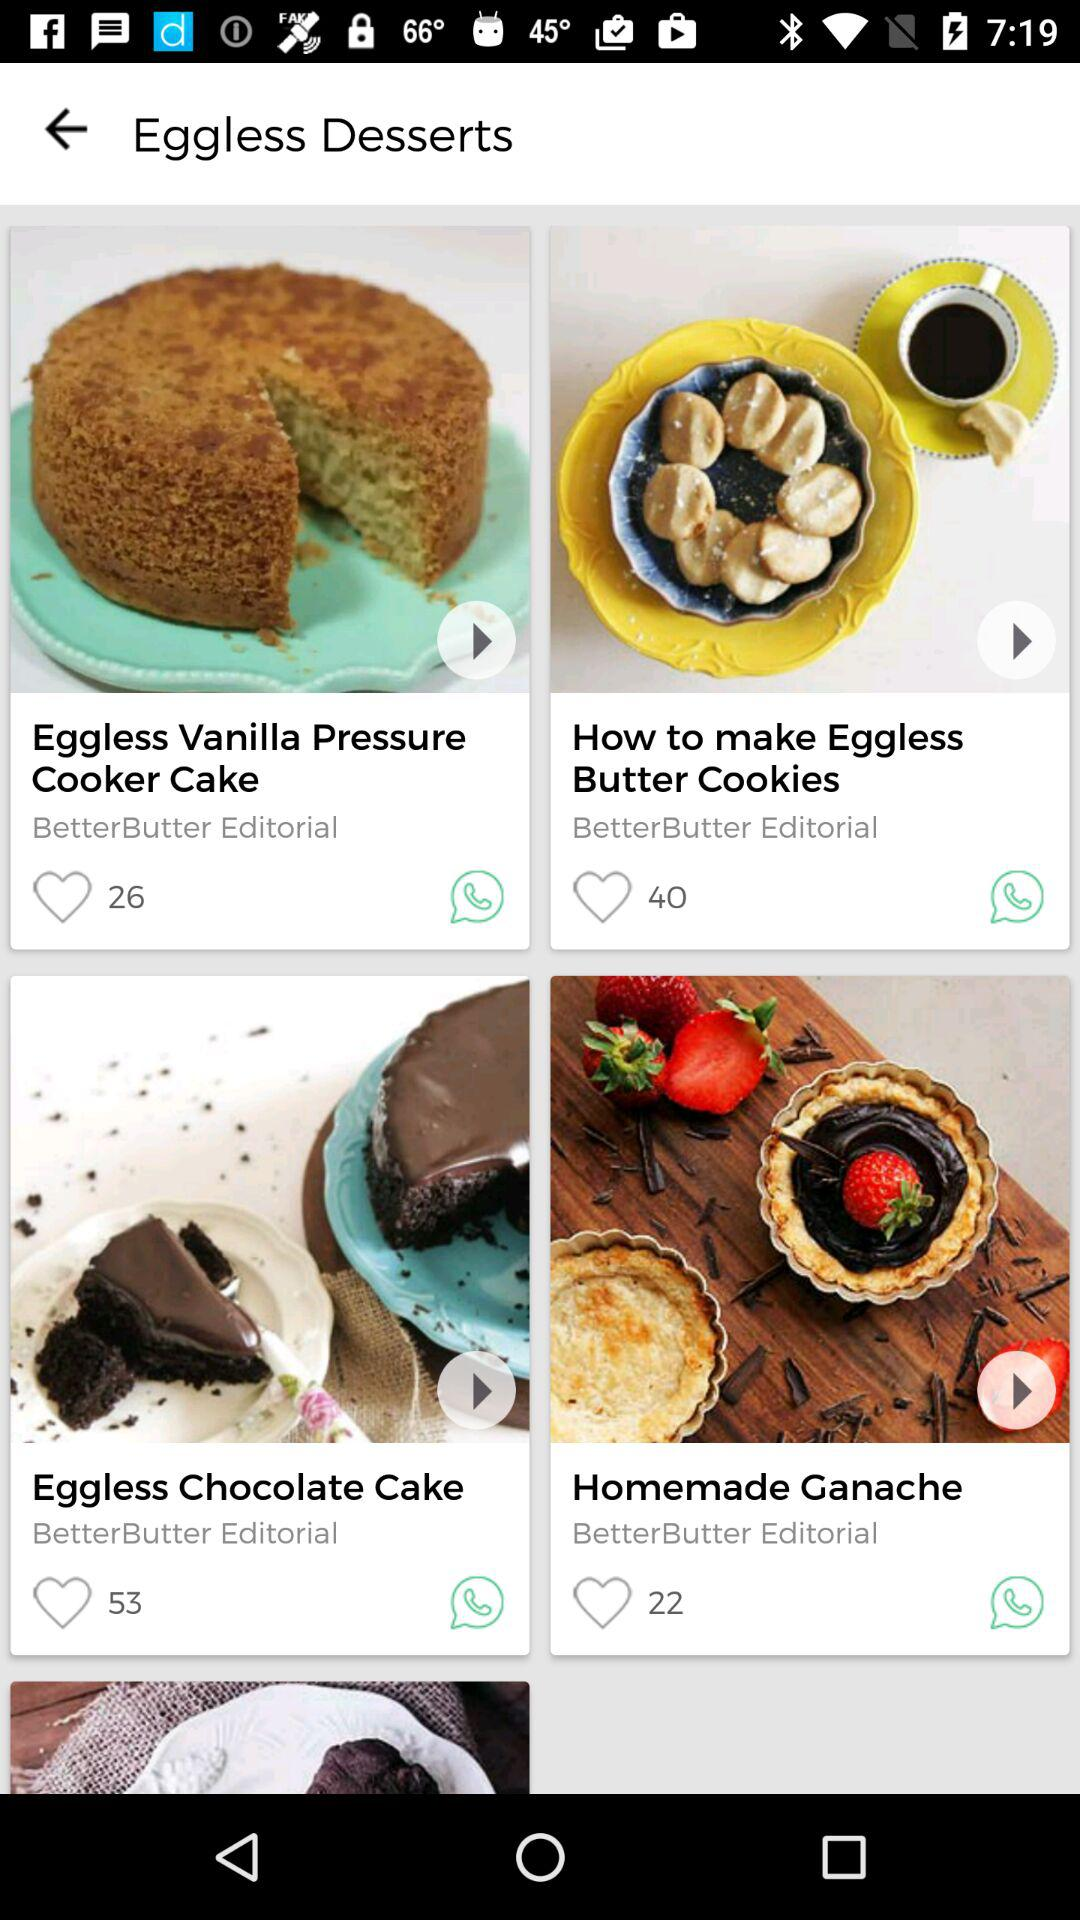What is the number of likes for the dish Eggless Chocolate Cake? The number of likes for the dish Eggless Chocolate Cake is 53. 